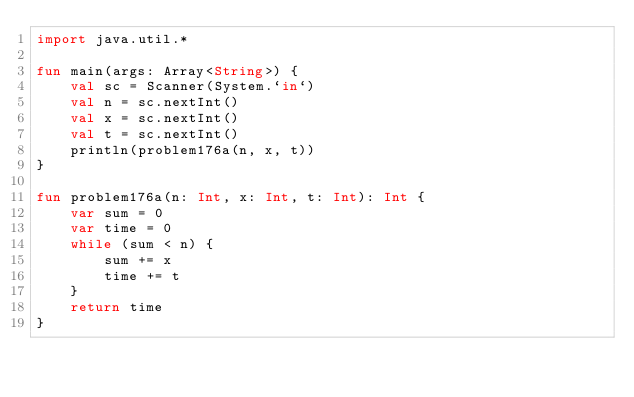Convert code to text. <code><loc_0><loc_0><loc_500><loc_500><_Kotlin_>import java.util.*

fun main(args: Array<String>) {
    val sc = Scanner(System.`in`)
    val n = sc.nextInt()
    val x = sc.nextInt()
    val t = sc.nextInt()
    println(problem176a(n, x, t))
}

fun problem176a(n: Int, x: Int, t: Int): Int {
    var sum = 0
    var time = 0
    while (sum < n) {
        sum += x
        time += t
    }
    return time
}</code> 